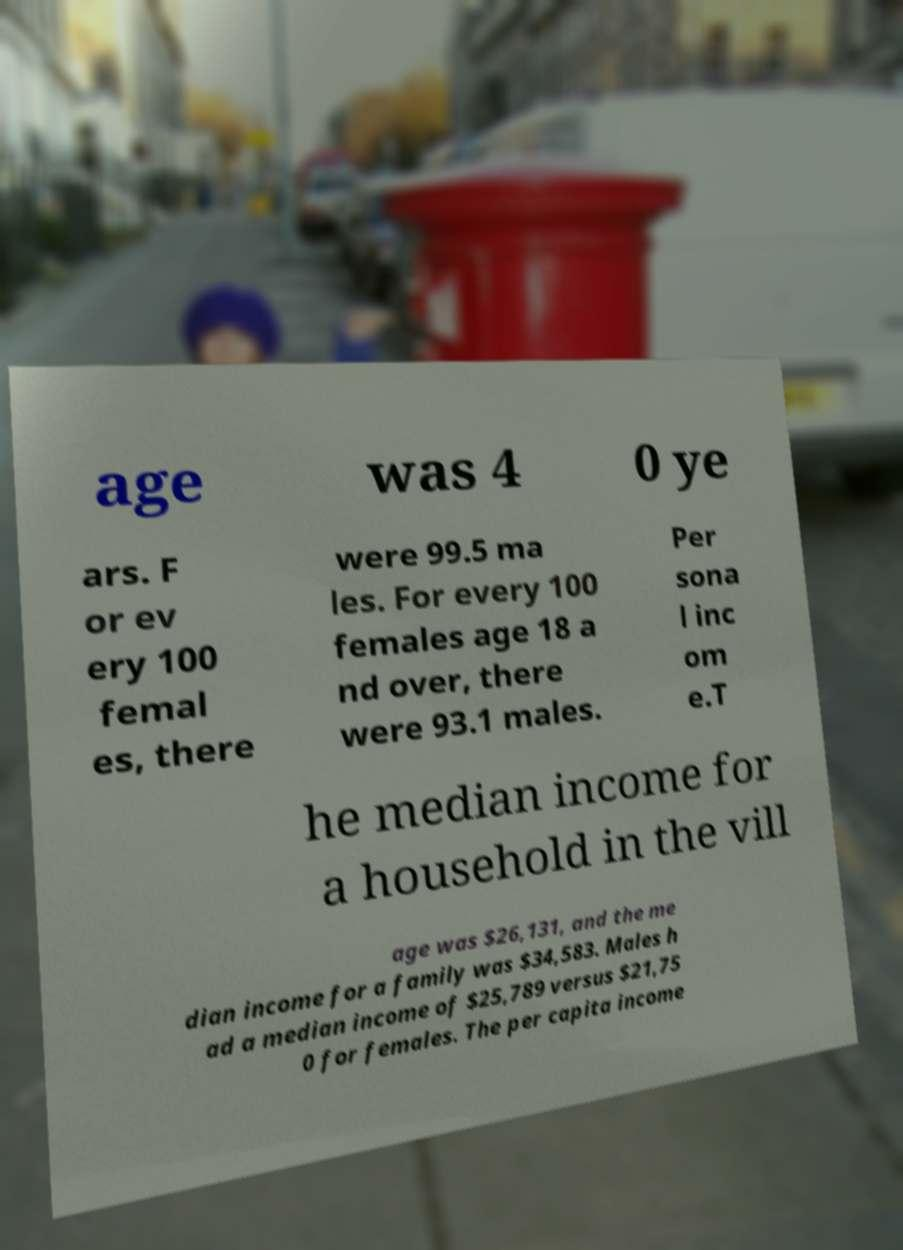Please read and relay the text visible in this image. What does it say? age was 4 0 ye ars. F or ev ery 100 femal es, there were 99.5 ma les. For every 100 females age 18 a nd over, there were 93.1 males. Per sona l inc om e.T he median income for a household in the vill age was $26,131, and the me dian income for a family was $34,583. Males h ad a median income of $25,789 versus $21,75 0 for females. The per capita income 